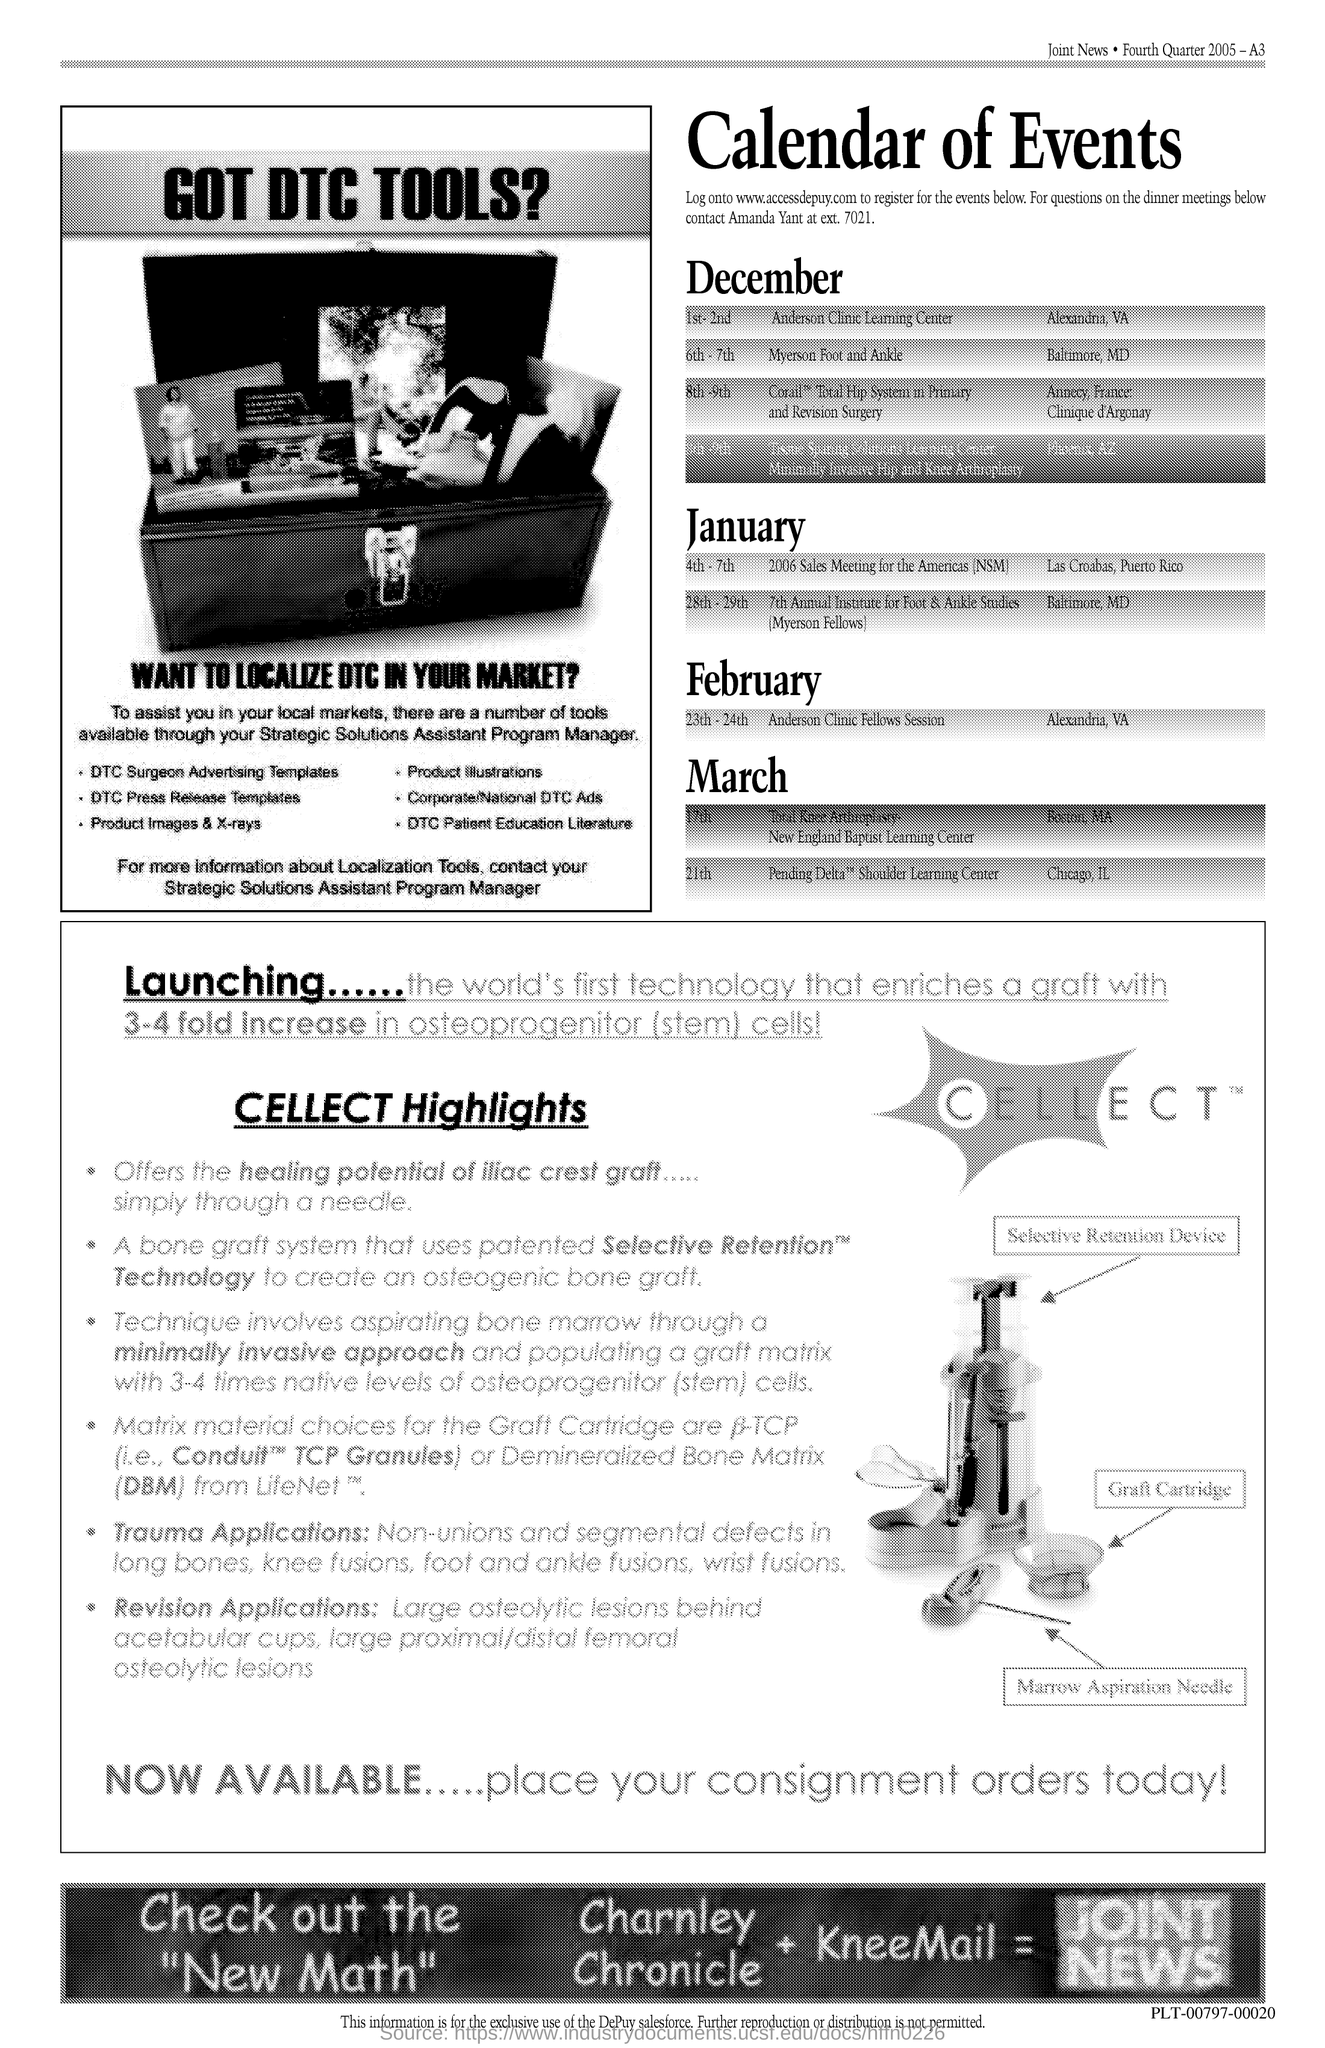What is the title of the document?
Keep it short and to the point. Calendar of Events. 